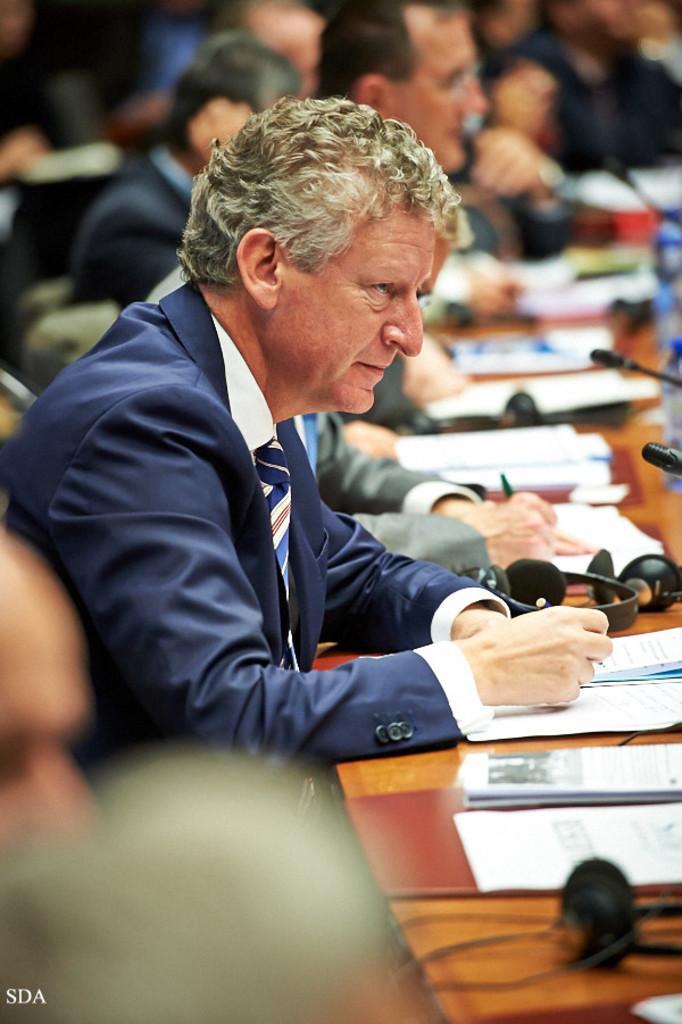In one or two sentences, can you explain what this image depicts? In this image, there are a few people. We can see the table with some objects like papers, headphones, microphones and bottles. 